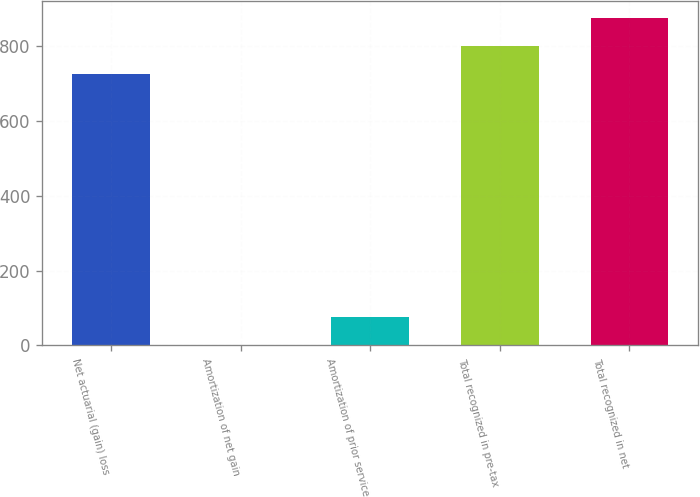Convert chart to OTSL. <chart><loc_0><loc_0><loc_500><loc_500><bar_chart><fcel>Net actuarial (gain) loss<fcel>Amortization of net gain<fcel>Amortization of prior service<fcel>Total recognized in pre-tax<fcel>Total recognized in net<nl><fcel>727.2<fcel>1.5<fcel>76.42<fcel>802.12<fcel>877.04<nl></chart> 